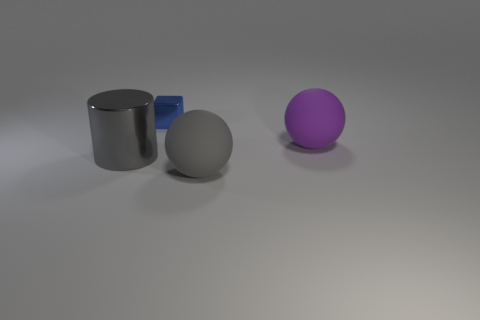There is a gray thing that is in front of the gray cylinder; what shape is it?
Ensure brevity in your answer.  Sphere. Is the blue cube made of the same material as the purple object?
Your answer should be very brief. No. Are there any other things that have the same size as the cylinder?
Ensure brevity in your answer.  Yes. There is a blue shiny object; what number of small objects are on the left side of it?
Your answer should be compact. 0. What is the shape of the big thing that is to the left of the shiny thing that is behind the purple rubber sphere?
Your answer should be compact. Cylinder. Is there any other thing that has the same shape as the large purple thing?
Give a very brief answer. Yes. Is the number of large purple objects on the left side of the purple rubber thing greater than the number of matte things?
Your response must be concise. No. There is a large gray metal cylinder in front of the purple rubber ball; what number of tiny objects are on the right side of it?
Give a very brief answer. 1. The big rubber object left of the large matte thing that is behind the big gray thing that is to the right of the tiny cube is what shape?
Keep it short and to the point. Sphere. How big is the gray matte object?
Provide a succinct answer. Large. 